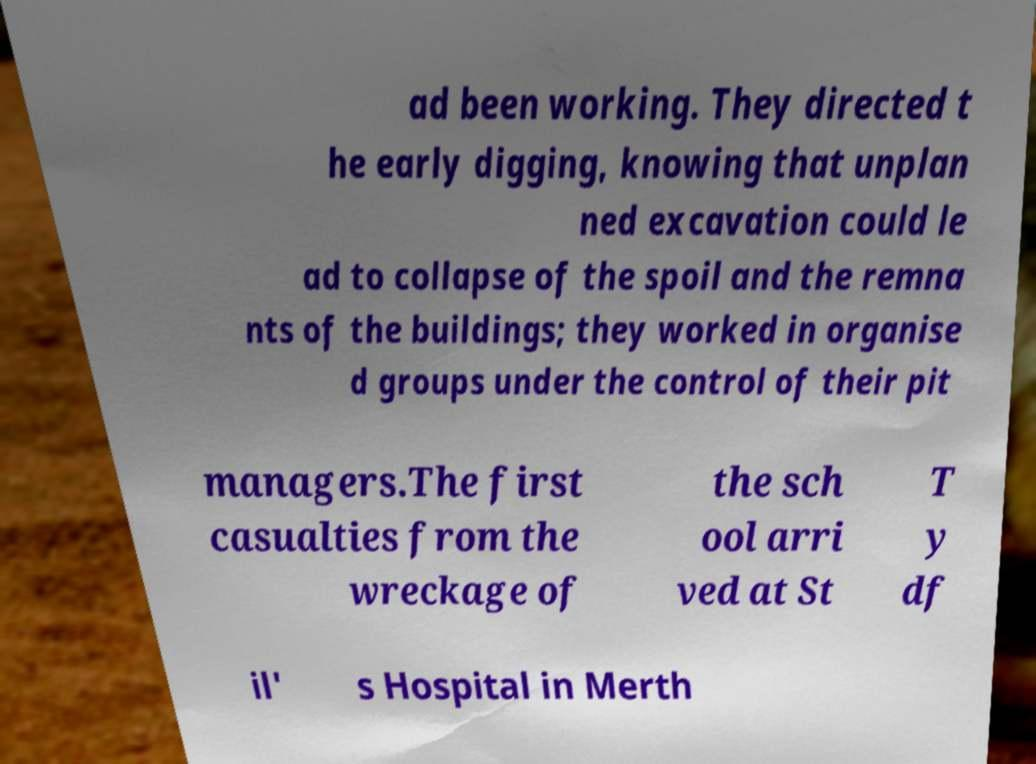Could you assist in decoding the text presented in this image and type it out clearly? ad been working. They directed t he early digging, knowing that unplan ned excavation could le ad to collapse of the spoil and the remna nts of the buildings; they worked in organise d groups under the control of their pit managers.The first casualties from the wreckage of the sch ool arri ved at St T y df il' s Hospital in Merth 